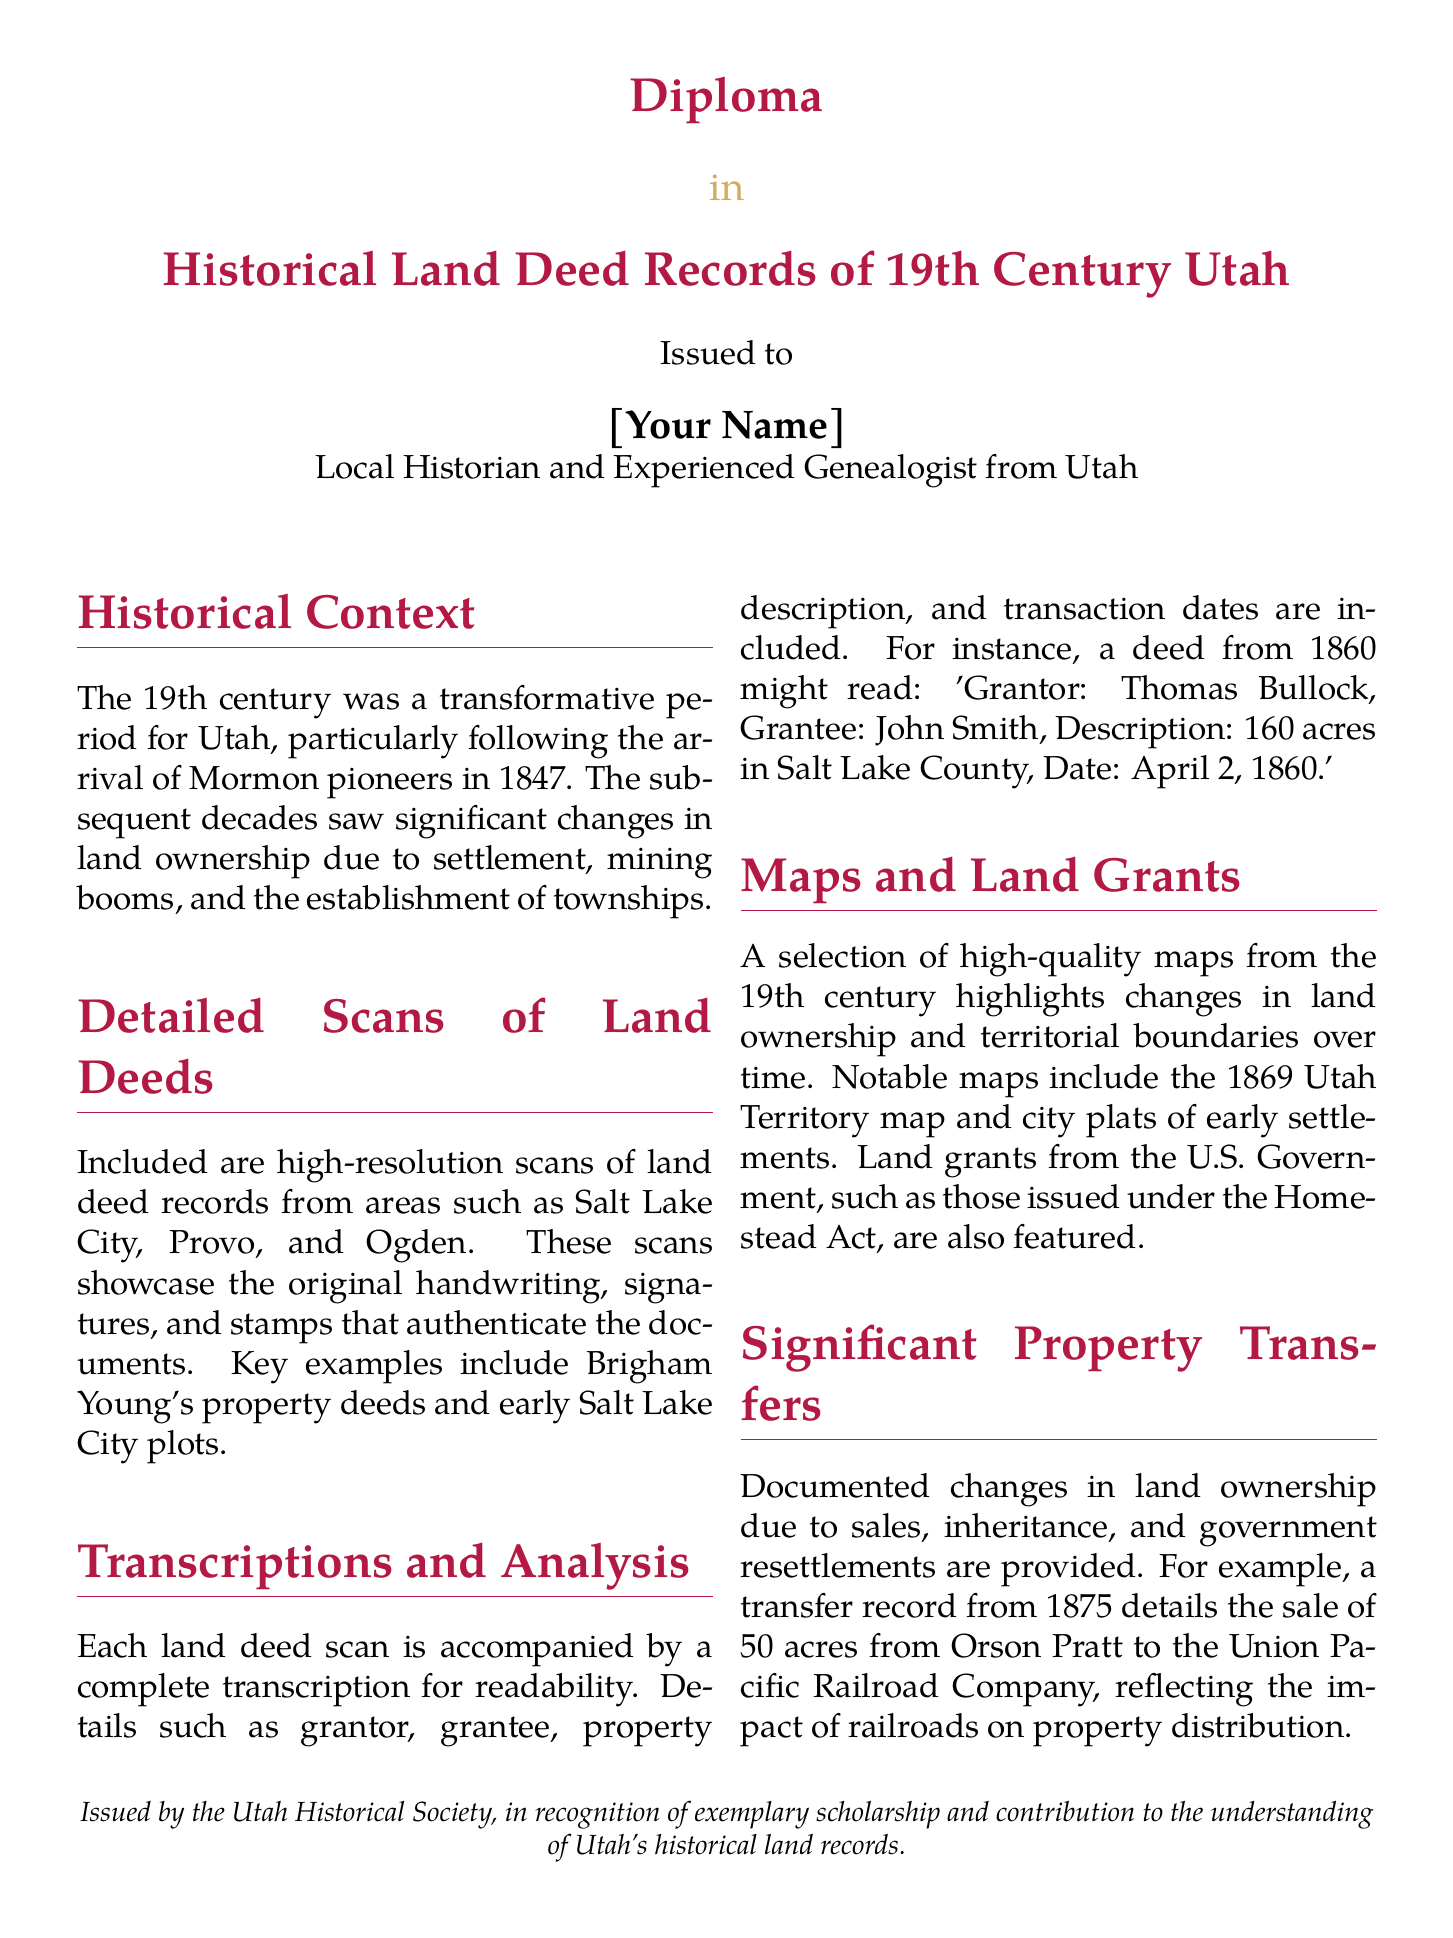What is the diploma awarded for? The diploma is awarded for the study of historical land deed records from the 19th century in Utah.
Answer: Historical Land Deed Records of 19th Century Utah Who issued the diploma? The diploma is issued by the Utah Historical Society.
Answer: Utah Historical Society What significant historical event is mentioned in relation to the 19th century? The arrival of Mormon pioneers in 1847 is a significant event highlighted in the document.
Answer: Mormon pioneers in 1847 What year might a featured deed record be from? A specific deed example mentioned is dated April 2, 1860.
Answer: 1860 Who is a notable figure mentioned in the land deed records? Brigham Young is mentioned as having property deeds included in the scans.
Answer: Brigham Young What type of maps are included in the document? The document includes high-quality maps from the 19th century, particularly an 1869 Utah Territory map.
Answer: 1869 Utah Territory map What was the transfer of land from Orson Pratt to whom? The record specifies a property transfer from Orson Pratt to the Union Pacific Railroad Company.
Answer: Union Pacific Railroad Company What trend in land ownership is discussed in the document? The document discusses changes in land ownership due to sales and government resettlements.
Answer: Sales and government resettlements 